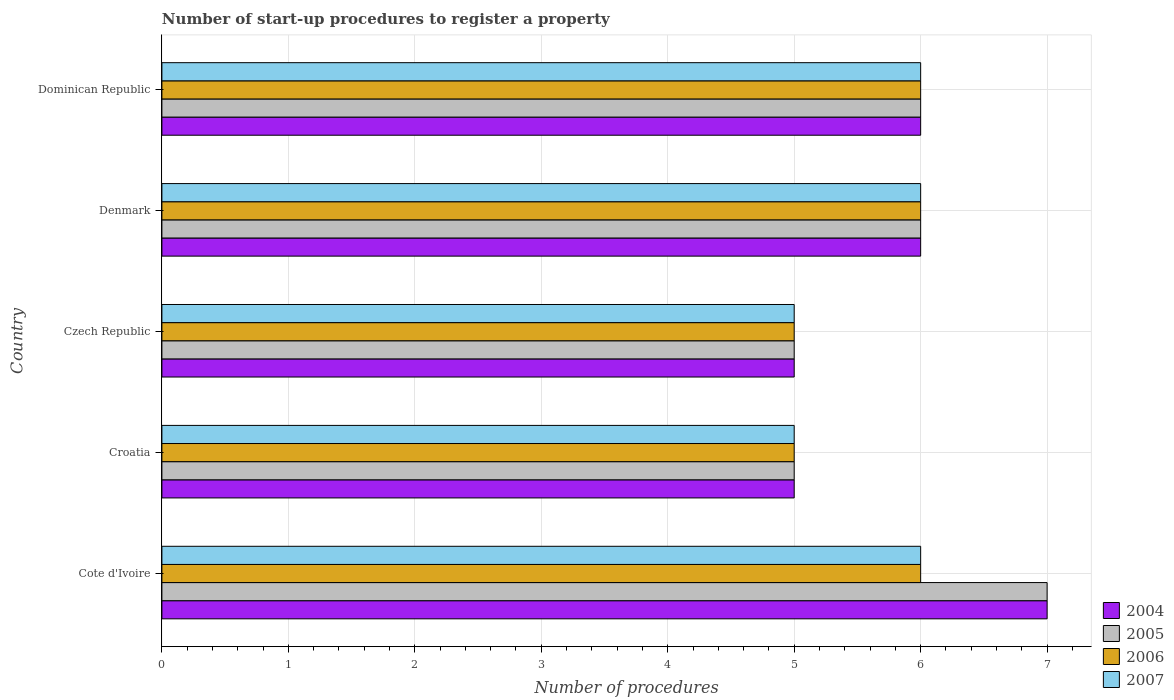How many groups of bars are there?
Give a very brief answer. 5. What is the number of procedures required to register a property in 2007 in Croatia?
Offer a very short reply. 5. Across all countries, what is the maximum number of procedures required to register a property in 2006?
Give a very brief answer. 6. Across all countries, what is the minimum number of procedures required to register a property in 2004?
Your response must be concise. 5. In which country was the number of procedures required to register a property in 2007 maximum?
Provide a succinct answer. Cote d'Ivoire. In which country was the number of procedures required to register a property in 2005 minimum?
Ensure brevity in your answer.  Croatia. What is the total number of procedures required to register a property in 2006 in the graph?
Provide a short and direct response. 28. What is the difference between the number of procedures required to register a property in 2007 in Croatia and that in Denmark?
Your response must be concise. -1. What is the difference between the number of procedures required to register a property in 2007 and number of procedures required to register a property in 2006 in Czech Republic?
Provide a succinct answer. 0. What is the ratio of the number of procedures required to register a property in 2006 in Czech Republic to that in Denmark?
Give a very brief answer. 0.83. Is the number of procedures required to register a property in 2007 in Cote d'Ivoire less than that in Croatia?
Your answer should be very brief. No. Is the difference between the number of procedures required to register a property in 2007 in Cote d'Ivoire and Czech Republic greater than the difference between the number of procedures required to register a property in 2006 in Cote d'Ivoire and Czech Republic?
Provide a succinct answer. No. What is the difference between the highest and the lowest number of procedures required to register a property in 2004?
Give a very brief answer. 2. In how many countries, is the number of procedures required to register a property in 2007 greater than the average number of procedures required to register a property in 2007 taken over all countries?
Offer a terse response. 3. Is the sum of the number of procedures required to register a property in 2005 in Cote d'Ivoire and Czech Republic greater than the maximum number of procedures required to register a property in 2004 across all countries?
Your response must be concise. Yes. What does the 2nd bar from the top in Croatia represents?
Offer a very short reply. 2006. Is it the case that in every country, the sum of the number of procedures required to register a property in 2006 and number of procedures required to register a property in 2005 is greater than the number of procedures required to register a property in 2007?
Your answer should be compact. Yes. Are all the bars in the graph horizontal?
Your answer should be compact. Yes. How many countries are there in the graph?
Offer a very short reply. 5. Are the values on the major ticks of X-axis written in scientific E-notation?
Offer a terse response. No. Does the graph contain any zero values?
Keep it short and to the point. No. Where does the legend appear in the graph?
Ensure brevity in your answer.  Bottom right. What is the title of the graph?
Ensure brevity in your answer.  Number of start-up procedures to register a property. Does "1960" appear as one of the legend labels in the graph?
Keep it short and to the point. No. What is the label or title of the X-axis?
Give a very brief answer. Number of procedures. What is the Number of procedures in 2004 in Croatia?
Your answer should be compact. 5. What is the Number of procedures in 2005 in Croatia?
Give a very brief answer. 5. What is the Number of procedures in 2006 in Croatia?
Give a very brief answer. 5. What is the Number of procedures of 2005 in Czech Republic?
Offer a very short reply. 5. What is the Number of procedures in 2006 in Czech Republic?
Give a very brief answer. 5. What is the Number of procedures in 2007 in Czech Republic?
Give a very brief answer. 5. What is the Number of procedures in 2004 in Denmark?
Offer a very short reply. 6. What is the Number of procedures in 2005 in Denmark?
Make the answer very short. 6. What is the Number of procedures of 2006 in Denmark?
Your answer should be very brief. 6. What is the Number of procedures in 2007 in Denmark?
Make the answer very short. 6. What is the Number of procedures of 2004 in Dominican Republic?
Provide a succinct answer. 6. What is the Number of procedures of 2005 in Dominican Republic?
Your response must be concise. 6. Across all countries, what is the maximum Number of procedures in 2004?
Your response must be concise. 7. Across all countries, what is the maximum Number of procedures in 2005?
Your answer should be compact. 7. Across all countries, what is the maximum Number of procedures in 2006?
Your response must be concise. 6. Across all countries, what is the minimum Number of procedures of 2004?
Ensure brevity in your answer.  5. What is the total Number of procedures in 2004 in the graph?
Your answer should be very brief. 29. What is the total Number of procedures in 2005 in the graph?
Provide a succinct answer. 29. What is the total Number of procedures of 2007 in the graph?
Give a very brief answer. 28. What is the difference between the Number of procedures of 2004 in Cote d'Ivoire and that in Croatia?
Offer a terse response. 2. What is the difference between the Number of procedures in 2005 in Cote d'Ivoire and that in Croatia?
Your answer should be compact. 2. What is the difference between the Number of procedures in 2006 in Cote d'Ivoire and that in Croatia?
Your response must be concise. 1. What is the difference between the Number of procedures of 2004 in Cote d'Ivoire and that in Denmark?
Ensure brevity in your answer.  1. What is the difference between the Number of procedures in 2005 in Cote d'Ivoire and that in Denmark?
Your answer should be compact. 1. What is the difference between the Number of procedures of 2007 in Cote d'Ivoire and that in Denmark?
Ensure brevity in your answer.  0. What is the difference between the Number of procedures of 2004 in Cote d'Ivoire and that in Dominican Republic?
Provide a short and direct response. 1. What is the difference between the Number of procedures of 2005 in Cote d'Ivoire and that in Dominican Republic?
Provide a short and direct response. 1. What is the difference between the Number of procedures of 2007 in Cote d'Ivoire and that in Dominican Republic?
Your response must be concise. 0. What is the difference between the Number of procedures of 2004 in Croatia and that in Denmark?
Offer a terse response. -1. What is the difference between the Number of procedures in 2004 in Czech Republic and that in Denmark?
Give a very brief answer. -1. What is the difference between the Number of procedures of 2006 in Czech Republic and that in Denmark?
Ensure brevity in your answer.  -1. What is the difference between the Number of procedures of 2006 in Czech Republic and that in Dominican Republic?
Your answer should be very brief. -1. What is the difference between the Number of procedures in 2007 in Czech Republic and that in Dominican Republic?
Provide a short and direct response. -1. What is the difference between the Number of procedures of 2006 in Denmark and that in Dominican Republic?
Offer a terse response. 0. What is the difference between the Number of procedures in 2004 in Cote d'Ivoire and the Number of procedures in 2005 in Croatia?
Provide a short and direct response. 2. What is the difference between the Number of procedures in 2004 in Cote d'Ivoire and the Number of procedures in 2006 in Croatia?
Your answer should be compact. 2. What is the difference between the Number of procedures of 2004 in Cote d'Ivoire and the Number of procedures of 2007 in Croatia?
Keep it short and to the point. 2. What is the difference between the Number of procedures of 2005 in Cote d'Ivoire and the Number of procedures of 2006 in Croatia?
Ensure brevity in your answer.  2. What is the difference between the Number of procedures in 2004 in Cote d'Ivoire and the Number of procedures in 2005 in Czech Republic?
Your answer should be very brief. 2. What is the difference between the Number of procedures of 2004 in Cote d'Ivoire and the Number of procedures of 2007 in Czech Republic?
Your answer should be compact. 2. What is the difference between the Number of procedures in 2005 in Cote d'Ivoire and the Number of procedures in 2007 in Czech Republic?
Give a very brief answer. 2. What is the difference between the Number of procedures in 2006 in Cote d'Ivoire and the Number of procedures in 2007 in Czech Republic?
Keep it short and to the point. 1. What is the difference between the Number of procedures in 2004 in Cote d'Ivoire and the Number of procedures in 2006 in Denmark?
Ensure brevity in your answer.  1. What is the difference between the Number of procedures of 2004 in Cote d'Ivoire and the Number of procedures of 2007 in Denmark?
Your answer should be compact. 1. What is the difference between the Number of procedures in 2005 in Cote d'Ivoire and the Number of procedures in 2007 in Denmark?
Provide a succinct answer. 1. What is the difference between the Number of procedures in 2006 in Cote d'Ivoire and the Number of procedures in 2007 in Denmark?
Give a very brief answer. 0. What is the difference between the Number of procedures in 2004 in Croatia and the Number of procedures in 2007 in Czech Republic?
Your answer should be compact. 0. What is the difference between the Number of procedures of 2006 in Croatia and the Number of procedures of 2007 in Czech Republic?
Provide a short and direct response. 0. What is the difference between the Number of procedures in 2004 in Croatia and the Number of procedures in 2006 in Denmark?
Your response must be concise. -1. What is the difference between the Number of procedures of 2005 in Croatia and the Number of procedures of 2007 in Dominican Republic?
Provide a short and direct response. -1. What is the difference between the Number of procedures in 2004 in Czech Republic and the Number of procedures in 2005 in Denmark?
Give a very brief answer. -1. What is the difference between the Number of procedures in 2004 in Czech Republic and the Number of procedures in 2006 in Denmark?
Ensure brevity in your answer.  -1. What is the difference between the Number of procedures of 2004 in Czech Republic and the Number of procedures of 2007 in Denmark?
Keep it short and to the point. -1. What is the difference between the Number of procedures in 2005 in Czech Republic and the Number of procedures in 2007 in Denmark?
Keep it short and to the point. -1. What is the difference between the Number of procedures in 2004 in Czech Republic and the Number of procedures in 2006 in Dominican Republic?
Keep it short and to the point. -1. What is the difference between the Number of procedures in 2005 in Czech Republic and the Number of procedures in 2006 in Dominican Republic?
Make the answer very short. -1. What is the difference between the Number of procedures of 2006 in Czech Republic and the Number of procedures of 2007 in Dominican Republic?
Give a very brief answer. -1. What is the difference between the Number of procedures in 2004 in Denmark and the Number of procedures in 2005 in Dominican Republic?
Keep it short and to the point. 0. What is the difference between the Number of procedures in 2004 and Number of procedures in 2006 in Cote d'Ivoire?
Make the answer very short. 1. What is the difference between the Number of procedures in 2005 and Number of procedures in 2006 in Cote d'Ivoire?
Offer a very short reply. 1. What is the difference between the Number of procedures in 2004 and Number of procedures in 2005 in Croatia?
Provide a succinct answer. 0. What is the difference between the Number of procedures in 2004 and Number of procedures in 2006 in Croatia?
Provide a succinct answer. 0. What is the difference between the Number of procedures in 2006 and Number of procedures in 2007 in Croatia?
Keep it short and to the point. 0. What is the difference between the Number of procedures of 2004 and Number of procedures of 2005 in Czech Republic?
Keep it short and to the point. 0. What is the difference between the Number of procedures in 2004 and Number of procedures in 2006 in Czech Republic?
Keep it short and to the point. 0. What is the difference between the Number of procedures in 2004 and Number of procedures in 2007 in Czech Republic?
Your response must be concise. 0. What is the difference between the Number of procedures in 2006 and Number of procedures in 2007 in Czech Republic?
Offer a terse response. 0. What is the difference between the Number of procedures in 2005 and Number of procedures in 2007 in Denmark?
Offer a terse response. 0. What is the difference between the Number of procedures of 2004 and Number of procedures of 2005 in Dominican Republic?
Give a very brief answer. 0. What is the difference between the Number of procedures of 2004 and Number of procedures of 2007 in Dominican Republic?
Ensure brevity in your answer.  0. What is the difference between the Number of procedures of 2005 and Number of procedures of 2006 in Dominican Republic?
Your response must be concise. 0. What is the ratio of the Number of procedures in 2004 in Cote d'Ivoire to that in Croatia?
Ensure brevity in your answer.  1.4. What is the ratio of the Number of procedures in 2006 in Cote d'Ivoire to that in Croatia?
Your answer should be very brief. 1.2. What is the ratio of the Number of procedures of 2006 in Cote d'Ivoire to that in Czech Republic?
Offer a very short reply. 1.2. What is the ratio of the Number of procedures in 2007 in Cote d'Ivoire to that in Dominican Republic?
Ensure brevity in your answer.  1. What is the ratio of the Number of procedures of 2004 in Croatia to that in Czech Republic?
Your response must be concise. 1. What is the ratio of the Number of procedures in 2006 in Croatia to that in Czech Republic?
Provide a succinct answer. 1. What is the ratio of the Number of procedures of 2004 in Croatia to that in Denmark?
Offer a very short reply. 0.83. What is the ratio of the Number of procedures in 2005 in Croatia to that in Denmark?
Keep it short and to the point. 0.83. What is the ratio of the Number of procedures of 2006 in Croatia to that in Denmark?
Your answer should be very brief. 0.83. What is the ratio of the Number of procedures of 2007 in Croatia to that in Denmark?
Give a very brief answer. 0.83. What is the ratio of the Number of procedures in 2004 in Croatia to that in Dominican Republic?
Provide a short and direct response. 0.83. What is the ratio of the Number of procedures in 2006 in Croatia to that in Dominican Republic?
Ensure brevity in your answer.  0.83. What is the ratio of the Number of procedures in 2007 in Czech Republic to that in Denmark?
Your answer should be very brief. 0.83. What is the ratio of the Number of procedures in 2004 in Czech Republic to that in Dominican Republic?
Provide a succinct answer. 0.83. What is the ratio of the Number of procedures of 2006 in Czech Republic to that in Dominican Republic?
Offer a very short reply. 0.83. What is the ratio of the Number of procedures of 2007 in Czech Republic to that in Dominican Republic?
Provide a short and direct response. 0.83. What is the ratio of the Number of procedures in 2004 in Denmark to that in Dominican Republic?
Offer a terse response. 1. What is the ratio of the Number of procedures in 2007 in Denmark to that in Dominican Republic?
Make the answer very short. 1. What is the difference between the highest and the second highest Number of procedures in 2004?
Offer a very short reply. 1. What is the difference between the highest and the second highest Number of procedures of 2006?
Make the answer very short. 0. What is the difference between the highest and the second highest Number of procedures in 2007?
Ensure brevity in your answer.  0. What is the difference between the highest and the lowest Number of procedures of 2004?
Offer a terse response. 2. What is the difference between the highest and the lowest Number of procedures in 2005?
Offer a terse response. 2. What is the difference between the highest and the lowest Number of procedures of 2007?
Keep it short and to the point. 1. 